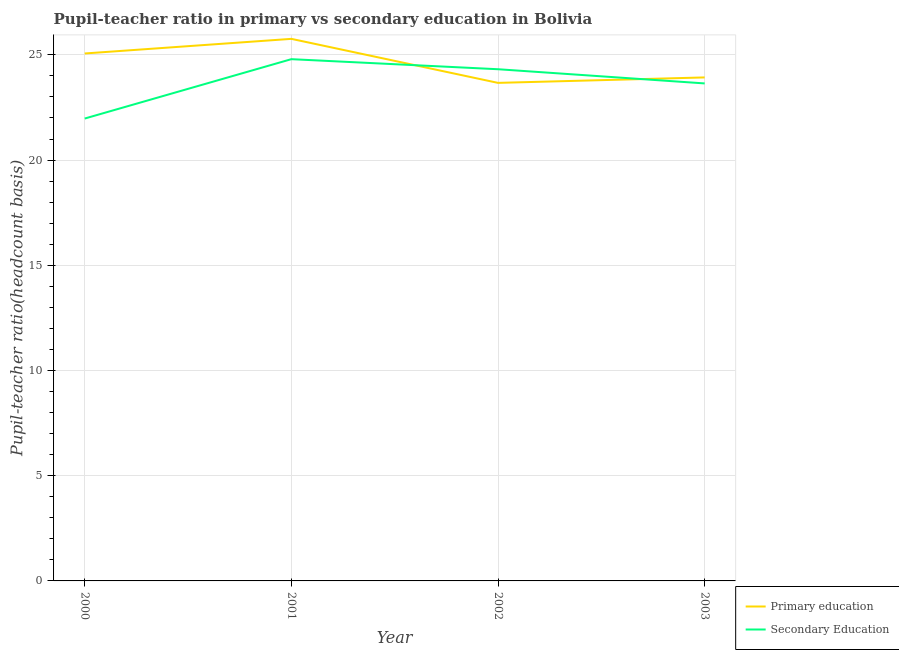What is the pupil-teacher ratio in primary education in 2001?
Keep it short and to the point. 25.76. Across all years, what is the maximum pupil-teacher ratio in primary education?
Your answer should be very brief. 25.76. Across all years, what is the minimum pupil teacher ratio on secondary education?
Your response must be concise. 21.97. In which year was the pupil-teacher ratio in primary education maximum?
Provide a succinct answer. 2001. What is the total pupil teacher ratio on secondary education in the graph?
Give a very brief answer. 94.73. What is the difference between the pupil teacher ratio on secondary education in 2001 and that in 2002?
Provide a short and direct response. 0.48. What is the difference between the pupil-teacher ratio in primary education in 2001 and the pupil teacher ratio on secondary education in 2000?
Your answer should be very brief. 3.79. What is the average pupil teacher ratio on secondary education per year?
Provide a short and direct response. 23.68. In the year 2002, what is the difference between the pupil-teacher ratio in primary education and pupil teacher ratio on secondary education?
Ensure brevity in your answer.  -0.65. In how many years, is the pupil-teacher ratio in primary education greater than 12?
Your response must be concise. 4. What is the ratio of the pupil teacher ratio on secondary education in 2000 to that in 2001?
Your answer should be very brief. 0.89. What is the difference between the highest and the second highest pupil teacher ratio on secondary education?
Provide a succinct answer. 0.48. What is the difference between the highest and the lowest pupil teacher ratio on secondary education?
Provide a succinct answer. 2.82. Is the sum of the pupil-teacher ratio in primary education in 2000 and 2003 greater than the maximum pupil teacher ratio on secondary education across all years?
Offer a terse response. Yes. Does the pupil teacher ratio on secondary education monotonically increase over the years?
Offer a terse response. No. Is the pupil teacher ratio on secondary education strictly greater than the pupil-teacher ratio in primary education over the years?
Offer a terse response. No. How many lines are there?
Provide a succinct answer. 2. How many years are there in the graph?
Offer a very short reply. 4. Does the graph contain grids?
Give a very brief answer. Yes. How many legend labels are there?
Provide a short and direct response. 2. How are the legend labels stacked?
Provide a succinct answer. Vertical. What is the title of the graph?
Give a very brief answer. Pupil-teacher ratio in primary vs secondary education in Bolivia. Does "Mobile cellular" appear as one of the legend labels in the graph?
Provide a short and direct response. No. What is the label or title of the Y-axis?
Make the answer very short. Pupil-teacher ratio(headcount basis). What is the Pupil-teacher ratio(headcount basis) of Primary education in 2000?
Your answer should be compact. 25.07. What is the Pupil-teacher ratio(headcount basis) in Secondary Education in 2000?
Ensure brevity in your answer.  21.97. What is the Pupil-teacher ratio(headcount basis) of Primary education in 2001?
Provide a succinct answer. 25.76. What is the Pupil-teacher ratio(headcount basis) of Secondary Education in 2001?
Your answer should be very brief. 24.79. What is the Pupil-teacher ratio(headcount basis) of Primary education in 2002?
Your answer should be compact. 23.67. What is the Pupil-teacher ratio(headcount basis) in Secondary Education in 2002?
Provide a succinct answer. 24.32. What is the Pupil-teacher ratio(headcount basis) of Primary education in 2003?
Your answer should be very brief. 23.93. What is the Pupil-teacher ratio(headcount basis) of Secondary Education in 2003?
Make the answer very short. 23.64. Across all years, what is the maximum Pupil-teacher ratio(headcount basis) of Primary education?
Provide a short and direct response. 25.76. Across all years, what is the maximum Pupil-teacher ratio(headcount basis) of Secondary Education?
Your answer should be very brief. 24.79. Across all years, what is the minimum Pupil-teacher ratio(headcount basis) of Primary education?
Offer a very short reply. 23.67. Across all years, what is the minimum Pupil-teacher ratio(headcount basis) of Secondary Education?
Make the answer very short. 21.97. What is the total Pupil-teacher ratio(headcount basis) in Primary education in the graph?
Give a very brief answer. 98.42. What is the total Pupil-teacher ratio(headcount basis) of Secondary Education in the graph?
Your answer should be very brief. 94.73. What is the difference between the Pupil-teacher ratio(headcount basis) of Primary education in 2000 and that in 2001?
Provide a succinct answer. -0.69. What is the difference between the Pupil-teacher ratio(headcount basis) of Secondary Education in 2000 and that in 2001?
Your answer should be very brief. -2.82. What is the difference between the Pupil-teacher ratio(headcount basis) of Primary education in 2000 and that in 2002?
Make the answer very short. 1.4. What is the difference between the Pupil-teacher ratio(headcount basis) in Secondary Education in 2000 and that in 2002?
Make the answer very short. -2.34. What is the difference between the Pupil-teacher ratio(headcount basis) of Primary education in 2000 and that in 2003?
Offer a very short reply. 1.14. What is the difference between the Pupil-teacher ratio(headcount basis) of Secondary Education in 2000 and that in 2003?
Your answer should be very brief. -1.67. What is the difference between the Pupil-teacher ratio(headcount basis) of Primary education in 2001 and that in 2002?
Keep it short and to the point. 2.09. What is the difference between the Pupil-teacher ratio(headcount basis) in Secondary Education in 2001 and that in 2002?
Provide a succinct answer. 0.48. What is the difference between the Pupil-teacher ratio(headcount basis) of Primary education in 2001 and that in 2003?
Make the answer very short. 1.83. What is the difference between the Pupil-teacher ratio(headcount basis) in Secondary Education in 2001 and that in 2003?
Offer a terse response. 1.15. What is the difference between the Pupil-teacher ratio(headcount basis) of Primary education in 2002 and that in 2003?
Keep it short and to the point. -0.26. What is the difference between the Pupil-teacher ratio(headcount basis) of Secondary Education in 2002 and that in 2003?
Your answer should be compact. 0.67. What is the difference between the Pupil-teacher ratio(headcount basis) in Primary education in 2000 and the Pupil-teacher ratio(headcount basis) in Secondary Education in 2001?
Give a very brief answer. 0.27. What is the difference between the Pupil-teacher ratio(headcount basis) in Primary education in 2000 and the Pupil-teacher ratio(headcount basis) in Secondary Education in 2002?
Your response must be concise. 0.75. What is the difference between the Pupil-teacher ratio(headcount basis) of Primary education in 2000 and the Pupil-teacher ratio(headcount basis) of Secondary Education in 2003?
Your response must be concise. 1.42. What is the difference between the Pupil-teacher ratio(headcount basis) of Primary education in 2001 and the Pupil-teacher ratio(headcount basis) of Secondary Education in 2002?
Offer a very short reply. 1.44. What is the difference between the Pupil-teacher ratio(headcount basis) of Primary education in 2001 and the Pupil-teacher ratio(headcount basis) of Secondary Education in 2003?
Ensure brevity in your answer.  2.12. What is the difference between the Pupil-teacher ratio(headcount basis) in Primary education in 2002 and the Pupil-teacher ratio(headcount basis) in Secondary Education in 2003?
Offer a very short reply. 0.03. What is the average Pupil-teacher ratio(headcount basis) of Primary education per year?
Provide a short and direct response. 24.61. What is the average Pupil-teacher ratio(headcount basis) of Secondary Education per year?
Ensure brevity in your answer.  23.68. In the year 2000, what is the difference between the Pupil-teacher ratio(headcount basis) in Primary education and Pupil-teacher ratio(headcount basis) in Secondary Education?
Give a very brief answer. 3.09. In the year 2001, what is the difference between the Pupil-teacher ratio(headcount basis) in Primary education and Pupil-teacher ratio(headcount basis) in Secondary Education?
Offer a very short reply. 0.97. In the year 2002, what is the difference between the Pupil-teacher ratio(headcount basis) of Primary education and Pupil-teacher ratio(headcount basis) of Secondary Education?
Your response must be concise. -0.65. In the year 2003, what is the difference between the Pupil-teacher ratio(headcount basis) in Primary education and Pupil-teacher ratio(headcount basis) in Secondary Education?
Provide a succinct answer. 0.29. What is the ratio of the Pupil-teacher ratio(headcount basis) in Secondary Education in 2000 to that in 2001?
Provide a succinct answer. 0.89. What is the ratio of the Pupil-teacher ratio(headcount basis) of Primary education in 2000 to that in 2002?
Offer a very short reply. 1.06. What is the ratio of the Pupil-teacher ratio(headcount basis) of Secondary Education in 2000 to that in 2002?
Give a very brief answer. 0.9. What is the ratio of the Pupil-teacher ratio(headcount basis) in Primary education in 2000 to that in 2003?
Provide a succinct answer. 1.05. What is the ratio of the Pupil-teacher ratio(headcount basis) of Secondary Education in 2000 to that in 2003?
Offer a terse response. 0.93. What is the ratio of the Pupil-teacher ratio(headcount basis) in Primary education in 2001 to that in 2002?
Provide a short and direct response. 1.09. What is the ratio of the Pupil-teacher ratio(headcount basis) of Secondary Education in 2001 to that in 2002?
Give a very brief answer. 1.02. What is the ratio of the Pupil-teacher ratio(headcount basis) of Primary education in 2001 to that in 2003?
Your response must be concise. 1.08. What is the ratio of the Pupil-teacher ratio(headcount basis) of Secondary Education in 2001 to that in 2003?
Your response must be concise. 1.05. What is the ratio of the Pupil-teacher ratio(headcount basis) of Primary education in 2002 to that in 2003?
Your answer should be compact. 0.99. What is the ratio of the Pupil-teacher ratio(headcount basis) of Secondary Education in 2002 to that in 2003?
Make the answer very short. 1.03. What is the difference between the highest and the second highest Pupil-teacher ratio(headcount basis) of Primary education?
Ensure brevity in your answer.  0.69. What is the difference between the highest and the second highest Pupil-teacher ratio(headcount basis) of Secondary Education?
Keep it short and to the point. 0.48. What is the difference between the highest and the lowest Pupil-teacher ratio(headcount basis) of Primary education?
Offer a very short reply. 2.09. What is the difference between the highest and the lowest Pupil-teacher ratio(headcount basis) of Secondary Education?
Keep it short and to the point. 2.82. 